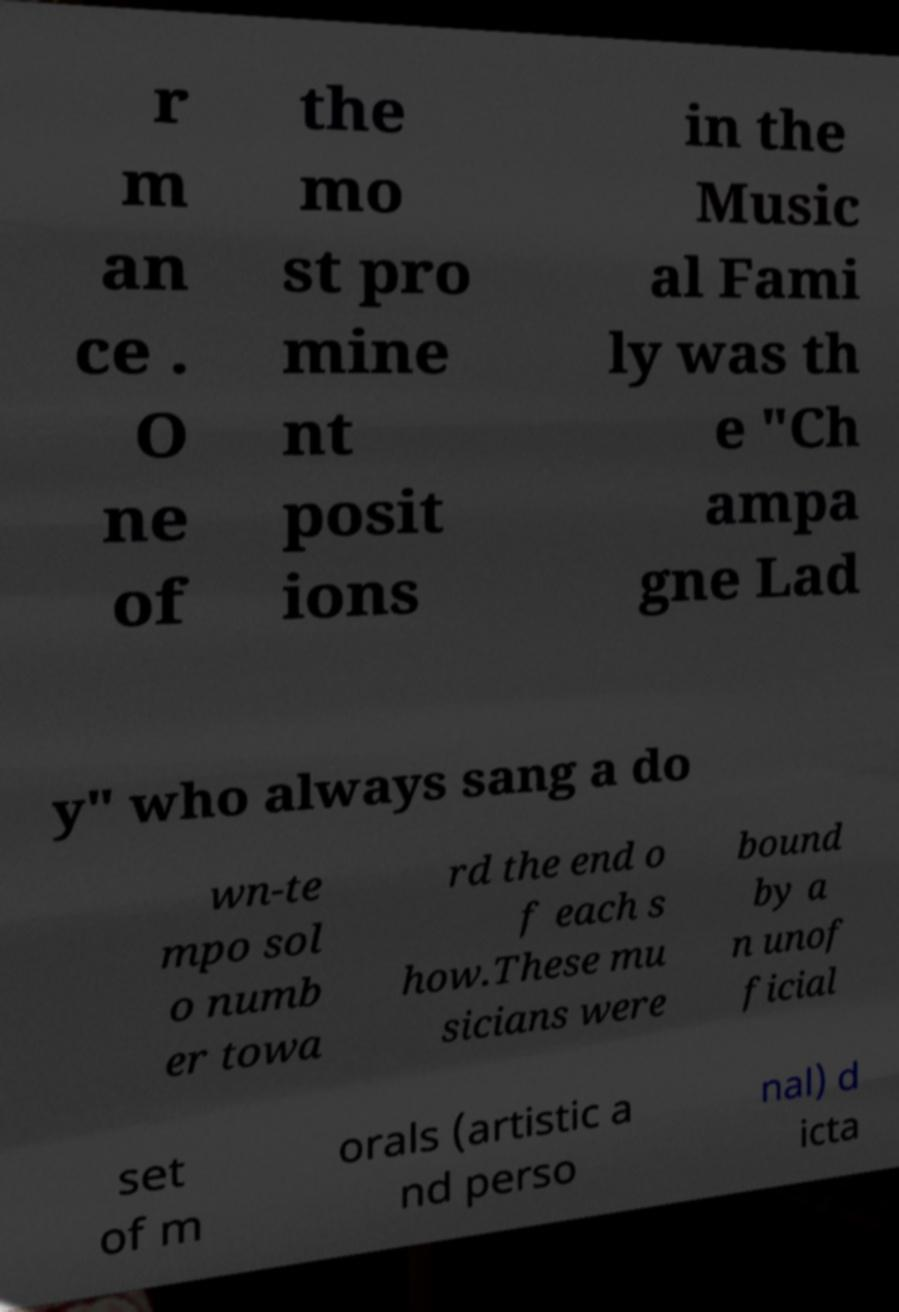Could you extract and type out the text from this image? r m an ce . O ne of the mo st pro mine nt posit ions in the Music al Fami ly was th e "Ch ampa gne Lad y" who always sang a do wn-te mpo sol o numb er towa rd the end o f each s how.These mu sicians were bound by a n unof ficial set of m orals (artistic a nd perso nal) d icta 